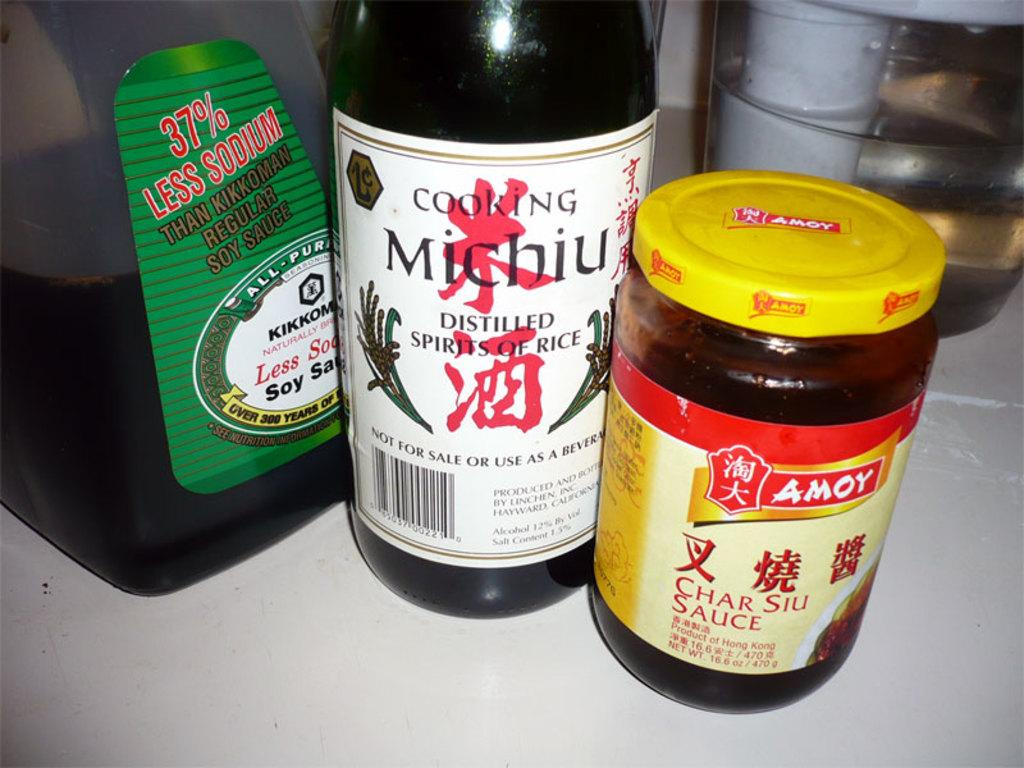<image>
Summarize the visual content of the image. Char Siu Sauce, soy sauce and Michiu all sit on the counter 